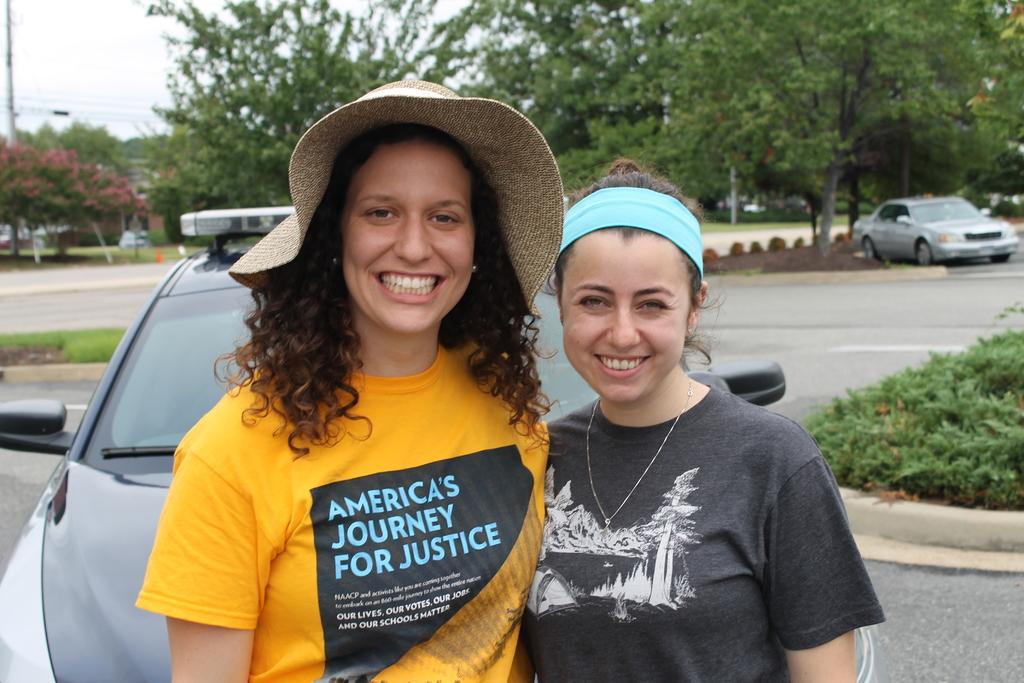Please provide a concise description of this image. In this image we can see women standing and smiling. In the background there are trees, sky, electric poles, electric cables, ground, road, motor vehicles and plants. 